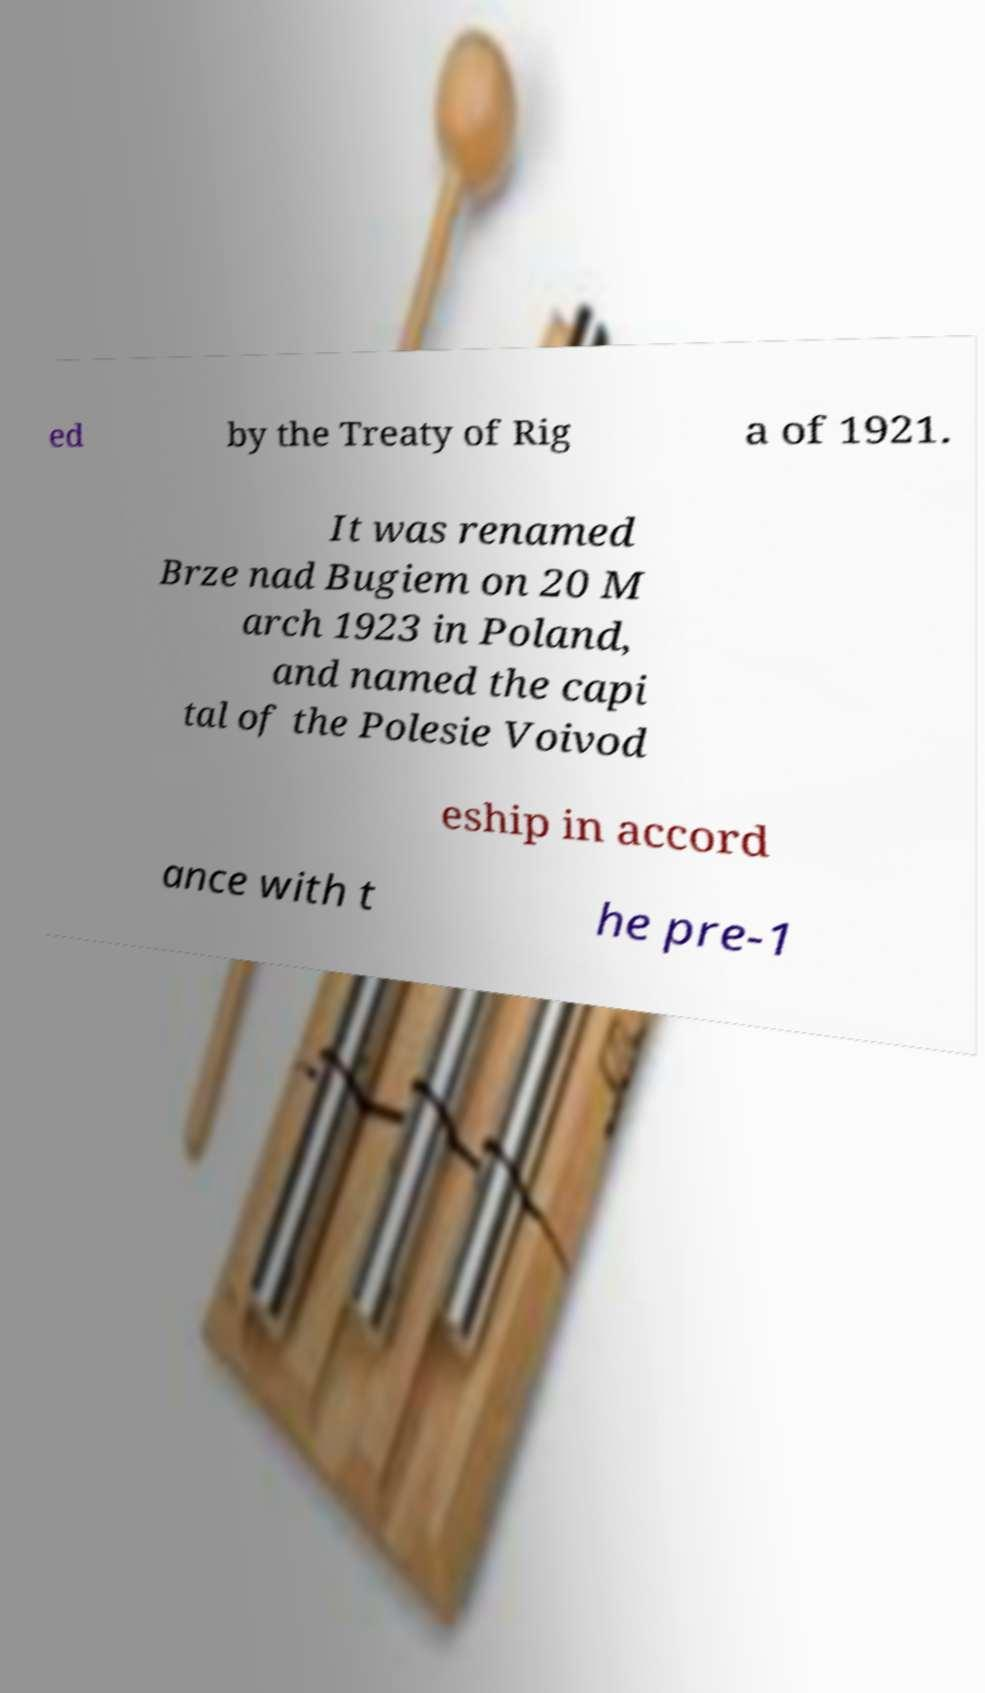Could you assist in decoding the text presented in this image and type it out clearly? ed by the Treaty of Rig a of 1921. It was renamed Brze nad Bugiem on 20 M arch 1923 in Poland, and named the capi tal of the Polesie Voivod eship in accord ance with t he pre-1 